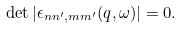Convert formula to latex. <formula><loc_0><loc_0><loc_500><loc_500>\det | \epsilon _ { n n ^ { \prime } , m m ^ { \prime } } ( q , \omega ) | = 0 .</formula> 